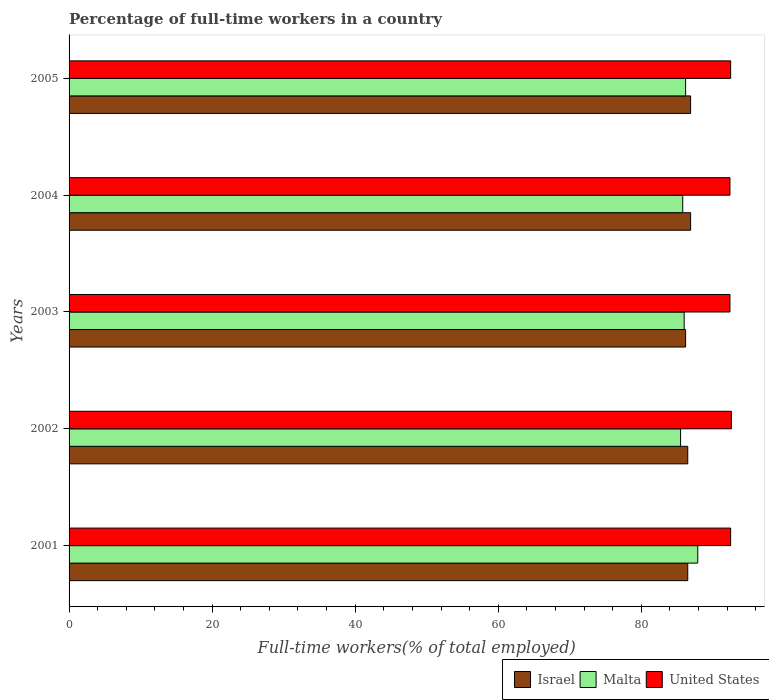How many groups of bars are there?
Provide a short and direct response. 5. Are the number of bars per tick equal to the number of legend labels?
Your answer should be compact. Yes. Are the number of bars on each tick of the Y-axis equal?
Your answer should be very brief. Yes. What is the label of the 3rd group of bars from the top?
Give a very brief answer. 2003. In how many cases, is the number of bars for a given year not equal to the number of legend labels?
Your answer should be compact. 0. What is the percentage of full-time workers in Israel in 2001?
Make the answer very short. 86.5. Across all years, what is the maximum percentage of full-time workers in Malta?
Offer a very short reply. 87.9. Across all years, what is the minimum percentage of full-time workers in United States?
Ensure brevity in your answer.  92.4. In which year was the percentage of full-time workers in United States maximum?
Your answer should be compact. 2002. What is the total percentage of full-time workers in Israel in the graph?
Keep it short and to the point. 433. What is the difference between the percentage of full-time workers in Malta in 2001 and that in 2002?
Keep it short and to the point. 2.4. What is the difference between the percentage of full-time workers in Israel in 2001 and the percentage of full-time workers in United States in 2002?
Keep it short and to the point. -6.1. What is the average percentage of full-time workers in United States per year?
Offer a terse response. 92.48. In the year 2004, what is the difference between the percentage of full-time workers in Malta and percentage of full-time workers in United States?
Your answer should be compact. -6.6. What is the ratio of the percentage of full-time workers in Israel in 2003 to that in 2005?
Keep it short and to the point. 0.99. Is the percentage of full-time workers in United States in 2002 less than that in 2004?
Your response must be concise. No. What is the difference between the highest and the second highest percentage of full-time workers in Israel?
Ensure brevity in your answer.  0. What is the difference between the highest and the lowest percentage of full-time workers in Malta?
Provide a succinct answer. 2.4. In how many years, is the percentage of full-time workers in Israel greater than the average percentage of full-time workers in Israel taken over all years?
Your response must be concise. 2. What does the 1st bar from the top in 2001 represents?
Your answer should be very brief. United States. Are all the bars in the graph horizontal?
Your answer should be very brief. Yes. How many years are there in the graph?
Your answer should be very brief. 5. What is the difference between two consecutive major ticks on the X-axis?
Make the answer very short. 20. Are the values on the major ticks of X-axis written in scientific E-notation?
Your answer should be very brief. No. Where does the legend appear in the graph?
Provide a short and direct response. Bottom right. How many legend labels are there?
Provide a succinct answer. 3. What is the title of the graph?
Give a very brief answer. Percentage of full-time workers in a country. What is the label or title of the X-axis?
Offer a very short reply. Full-time workers(% of total employed). What is the Full-time workers(% of total employed) of Israel in 2001?
Provide a short and direct response. 86.5. What is the Full-time workers(% of total employed) in Malta in 2001?
Provide a short and direct response. 87.9. What is the Full-time workers(% of total employed) in United States in 2001?
Offer a terse response. 92.5. What is the Full-time workers(% of total employed) in Israel in 2002?
Give a very brief answer. 86.5. What is the Full-time workers(% of total employed) of Malta in 2002?
Make the answer very short. 85.5. What is the Full-time workers(% of total employed) in United States in 2002?
Your answer should be compact. 92.6. What is the Full-time workers(% of total employed) of Israel in 2003?
Provide a short and direct response. 86.2. What is the Full-time workers(% of total employed) in Malta in 2003?
Your answer should be compact. 86. What is the Full-time workers(% of total employed) of United States in 2003?
Your response must be concise. 92.4. What is the Full-time workers(% of total employed) of Israel in 2004?
Your response must be concise. 86.9. What is the Full-time workers(% of total employed) in Malta in 2004?
Your answer should be very brief. 85.8. What is the Full-time workers(% of total employed) of United States in 2004?
Provide a succinct answer. 92.4. What is the Full-time workers(% of total employed) in Israel in 2005?
Offer a very short reply. 86.9. What is the Full-time workers(% of total employed) in Malta in 2005?
Ensure brevity in your answer.  86.2. What is the Full-time workers(% of total employed) in United States in 2005?
Make the answer very short. 92.5. Across all years, what is the maximum Full-time workers(% of total employed) of Israel?
Offer a very short reply. 86.9. Across all years, what is the maximum Full-time workers(% of total employed) in Malta?
Make the answer very short. 87.9. Across all years, what is the maximum Full-time workers(% of total employed) in United States?
Ensure brevity in your answer.  92.6. Across all years, what is the minimum Full-time workers(% of total employed) of Israel?
Offer a very short reply. 86.2. Across all years, what is the minimum Full-time workers(% of total employed) of Malta?
Your answer should be compact. 85.5. Across all years, what is the minimum Full-time workers(% of total employed) in United States?
Provide a short and direct response. 92.4. What is the total Full-time workers(% of total employed) of Israel in the graph?
Keep it short and to the point. 433. What is the total Full-time workers(% of total employed) in Malta in the graph?
Keep it short and to the point. 431.4. What is the total Full-time workers(% of total employed) of United States in the graph?
Keep it short and to the point. 462.4. What is the difference between the Full-time workers(% of total employed) in Israel in 2001 and that in 2002?
Offer a very short reply. 0. What is the difference between the Full-time workers(% of total employed) in United States in 2001 and that in 2002?
Provide a succinct answer. -0.1. What is the difference between the Full-time workers(% of total employed) in Israel in 2001 and that in 2003?
Your response must be concise. 0.3. What is the difference between the Full-time workers(% of total employed) of Israel in 2001 and that in 2004?
Offer a terse response. -0.4. What is the difference between the Full-time workers(% of total employed) of Malta in 2001 and that in 2004?
Your answer should be very brief. 2.1. What is the difference between the Full-time workers(% of total employed) in United States in 2001 and that in 2004?
Provide a short and direct response. 0.1. What is the difference between the Full-time workers(% of total employed) in Israel in 2001 and that in 2005?
Keep it short and to the point. -0.4. What is the difference between the Full-time workers(% of total employed) in Israel in 2002 and that in 2003?
Provide a succinct answer. 0.3. What is the difference between the Full-time workers(% of total employed) in Malta in 2002 and that in 2003?
Ensure brevity in your answer.  -0.5. What is the difference between the Full-time workers(% of total employed) in United States in 2002 and that in 2003?
Give a very brief answer. 0.2. What is the difference between the Full-time workers(% of total employed) of Malta in 2002 and that in 2004?
Ensure brevity in your answer.  -0.3. What is the difference between the Full-time workers(% of total employed) in Israel in 2002 and that in 2005?
Keep it short and to the point. -0.4. What is the difference between the Full-time workers(% of total employed) of United States in 2003 and that in 2004?
Your response must be concise. 0. What is the difference between the Full-time workers(% of total employed) of Israel in 2003 and that in 2005?
Your answer should be very brief. -0.7. What is the difference between the Full-time workers(% of total employed) of Malta in 2003 and that in 2005?
Your answer should be compact. -0.2. What is the difference between the Full-time workers(% of total employed) of Israel in 2004 and that in 2005?
Provide a short and direct response. 0. What is the difference between the Full-time workers(% of total employed) of Malta in 2004 and that in 2005?
Provide a succinct answer. -0.4. What is the difference between the Full-time workers(% of total employed) in United States in 2004 and that in 2005?
Your answer should be compact. -0.1. What is the difference between the Full-time workers(% of total employed) in Israel in 2001 and the Full-time workers(% of total employed) in United States in 2002?
Make the answer very short. -6.1. What is the difference between the Full-time workers(% of total employed) of Malta in 2001 and the Full-time workers(% of total employed) of United States in 2002?
Provide a succinct answer. -4.7. What is the difference between the Full-time workers(% of total employed) in Israel in 2001 and the Full-time workers(% of total employed) in Malta in 2003?
Your response must be concise. 0.5. What is the difference between the Full-time workers(% of total employed) of Malta in 2001 and the Full-time workers(% of total employed) of United States in 2003?
Your response must be concise. -4.5. What is the difference between the Full-time workers(% of total employed) of Israel in 2001 and the Full-time workers(% of total employed) of United States in 2004?
Keep it short and to the point. -5.9. What is the difference between the Full-time workers(% of total employed) in Malta in 2001 and the Full-time workers(% of total employed) in United States in 2004?
Your answer should be very brief. -4.5. What is the difference between the Full-time workers(% of total employed) in Israel in 2002 and the Full-time workers(% of total employed) in Malta in 2003?
Provide a succinct answer. 0.5. What is the difference between the Full-time workers(% of total employed) of Israel in 2002 and the Full-time workers(% of total employed) of United States in 2003?
Offer a very short reply. -5.9. What is the difference between the Full-time workers(% of total employed) of Israel in 2002 and the Full-time workers(% of total employed) of United States in 2004?
Your answer should be very brief. -5.9. What is the difference between the Full-time workers(% of total employed) of Malta in 2002 and the Full-time workers(% of total employed) of United States in 2004?
Offer a very short reply. -6.9. What is the difference between the Full-time workers(% of total employed) in Israel in 2003 and the Full-time workers(% of total employed) in United States in 2004?
Provide a short and direct response. -6.2. What is the difference between the Full-time workers(% of total employed) of Israel in 2003 and the Full-time workers(% of total employed) of Malta in 2005?
Give a very brief answer. 0. What is the difference between the Full-time workers(% of total employed) in Israel in 2003 and the Full-time workers(% of total employed) in United States in 2005?
Your response must be concise. -6.3. What is the difference between the Full-time workers(% of total employed) of Israel in 2004 and the Full-time workers(% of total employed) of Malta in 2005?
Your answer should be very brief. 0.7. What is the difference between the Full-time workers(% of total employed) of Israel in 2004 and the Full-time workers(% of total employed) of United States in 2005?
Your answer should be compact. -5.6. What is the difference between the Full-time workers(% of total employed) in Malta in 2004 and the Full-time workers(% of total employed) in United States in 2005?
Provide a succinct answer. -6.7. What is the average Full-time workers(% of total employed) of Israel per year?
Provide a succinct answer. 86.6. What is the average Full-time workers(% of total employed) in Malta per year?
Keep it short and to the point. 86.28. What is the average Full-time workers(% of total employed) of United States per year?
Offer a very short reply. 92.48. In the year 2001, what is the difference between the Full-time workers(% of total employed) of Israel and Full-time workers(% of total employed) of United States?
Keep it short and to the point. -6. In the year 2002, what is the difference between the Full-time workers(% of total employed) in Malta and Full-time workers(% of total employed) in United States?
Your answer should be very brief. -7.1. In the year 2003, what is the difference between the Full-time workers(% of total employed) of Israel and Full-time workers(% of total employed) of Malta?
Provide a succinct answer. 0.2. In the year 2003, what is the difference between the Full-time workers(% of total employed) of Malta and Full-time workers(% of total employed) of United States?
Ensure brevity in your answer.  -6.4. In the year 2004, what is the difference between the Full-time workers(% of total employed) of Israel and Full-time workers(% of total employed) of United States?
Your answer should be compact. -5.5. In the year 2005, what is the difference between the Full-time workers(% of total employed) of Israel and Full-time workers(% of total employed) of United States?
Make the answer very short. -5.6. In the year 2005, what is the difference between the Full-time workers(% of total employed) of Malta and Full-time workers(% of total employed) of United States?
Offer a terse response. -6.3. What is the ratio of the Full-time workers(% of total employed) in Israel in 2001 to that in 2002?
Your answer should be compact. 1. What is the ratio of the Full-time workers(% of total employed) in Malta in 2001 to that in 2002?
Make the answer very short. 1.03. What is the ratio of the Full-time workers(% of total employed) in United States in 2001 to that in 2002?
Ensure brevity in your answer.  1. What is the ratio of the Full-time workers(% of total employed) of Israel in 2001 to that in 2003?
Your answer should be very brief. 1. What is the ratio of the Full-time workers(% of total employed) in Malta in 2001 to that in 2003?
Provide a short and direct response. 1.02. What is the ratio of the Full-time workers(% of total employed) of Israel in 2001 to that in 2004?
Offer a very short reply. 1. What is the ratio of the Full-time workers(% of total employed) in Malta in 2001 to that in 2004?
Offer a terse response. 1.02. What is the ratio of the Full-time workers(% of total employed) in Malta in 2001 to that in 2005?
Give a very brief answer. 1.02. What is the ratio of the Full-time workers(% of total employed) in United States in 2001 to that in 2005?
Keep it short and to the point. 1. What is the ratio of the Full-time workers(% of total employed) of Israel in 2002 to that in 2003?
Your answer should be very brief. 1. What is the ratio of the Full-time workers(% of total employed) of Malta in 2002 to that in 2003?
Give a very brief answer. 0.99. What is the ratio of the Full-time workers(% of total employed) in United States in 2002 to that in 2005?
Make the answer very short. 1. What is the ratio of the Full-time workers(% of total employed) in United States in 2003 to that in 2004?
Provide a short and direct response. 1. What is the ratio of the Full-time workers(% of total employed) of Israel in 2003 to that in 2005?
Your response must be concise. 0.99. What is the ratio of the Full-time workers(% of total employed) of United States in 2003 to that in 2005?
Ensure brevity in your answer.  1. What is the ratio of the Full-time workers(% of total employed) in Israel in 2004 to that in 2005?
Ensure brevity in your answer.  1. What is the ratio of the Full-time workers(% of total employed) in Malta in 2004 to that in 2005?
Keep it short and to the point. 1. What is the difference between the highest and the second highest Full-time workers(% of total employed) in Israel?
Your answer should be compact. 0. What is the difference between the highest and the lowest Full-time workers(% of total employed) of Israel?
Your answer should be compact. 0.7. What is the difference between the highest and the lowest Full-time workers(% of total employed) in Malta?
Your response must be concise. 2.4. What is the difference between the highest and the lowest Full-time workers(% of total employed) of United States?
Make the answer very short. 0.2. 